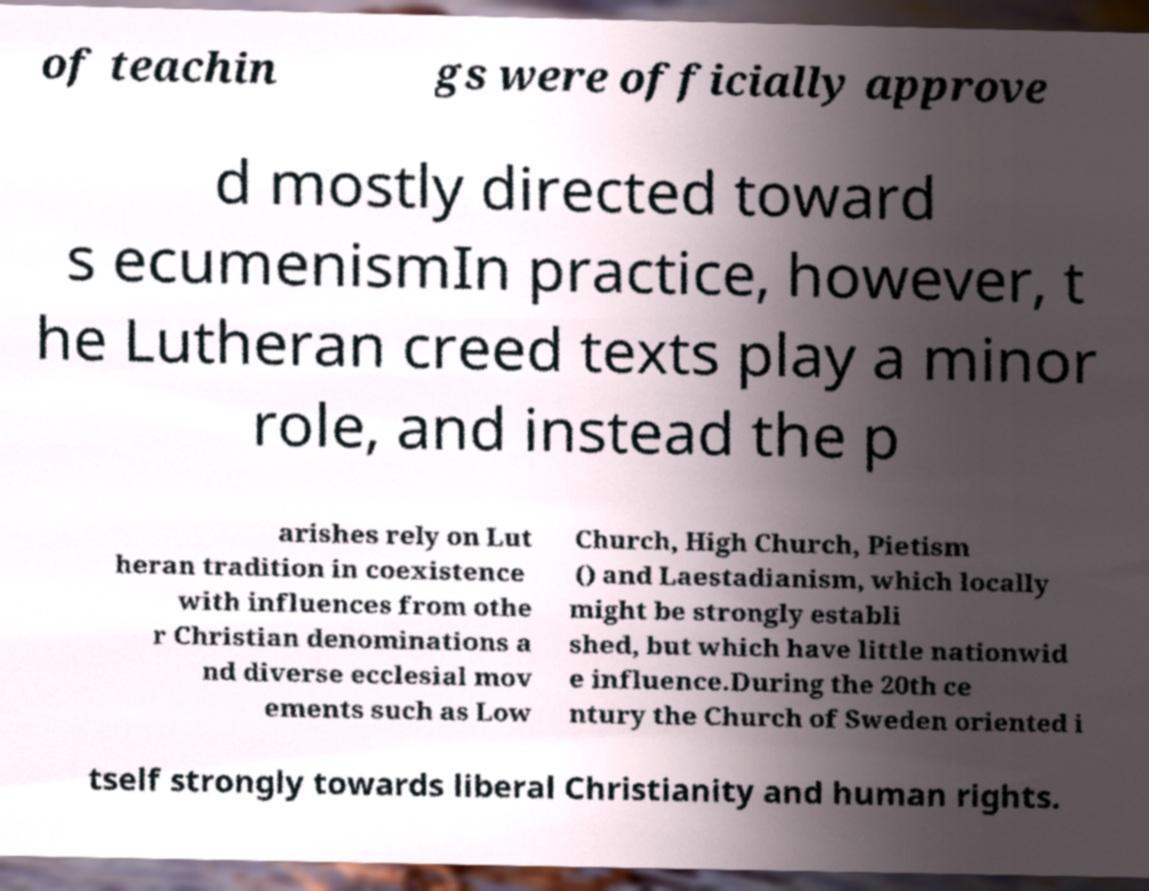Could you assist in decoding the text presented in this image and type it out clearly? of teachin gs were officially approve d mostly directed toward s ecumenismIn practice, however, t he Lutheran creed texts play a minor role, and instead the p arishes rely on Lut heran tradition in coexistence with influences from othe r Christian denominations a nd diverse ecclesial mov ements such as Low Church, High Church, Pietism () and Laestadianism, which locally might be strongly establi shed, but which have little nationwid e influence.During the 20th ce ntury the Church of Sweden oriented i tself strongly towards liberal Christianity and human rights. 